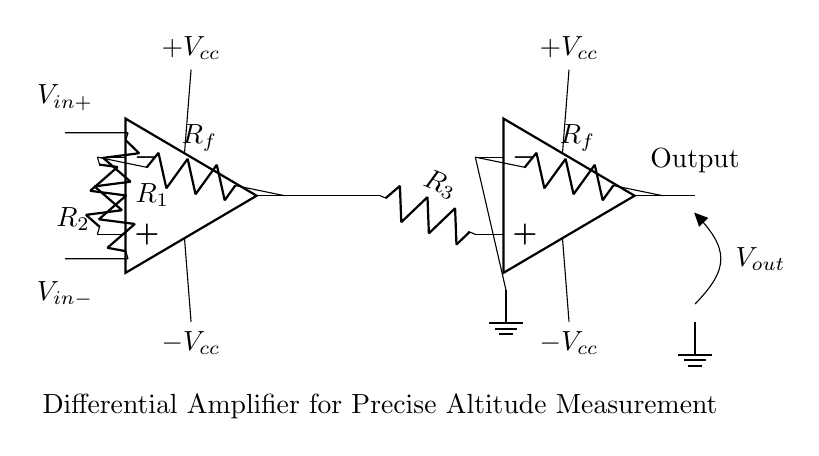What are the two main inputs to the circuit? The main inputs to this differential amplifier circuit are labeled as V_in+ and V_in-. These are the two signal inputs that the amplifier will process.
Answer: V_in+ and V_in- What is the function of the feedback resistors in this circuit? The feedback resistors, labeled R_f, regulate the gain of the amplifier by providing feedback from the output to the inverting input, stabilizing the circuit's performance and controlling the amplifier's output voltage based on the input signals.
Answer: Control gain How many operational amplifiers are used in this circuit? Upon examining the circuit, there are two operational amplifiers present, denoted as opamp1 and opamp2. Each serves a distinct stage in the amplification process.
Answer: Two What is the output voltage of the circuit labeled as? The output voltage from this differential amplifier is labeled as V_out, which represents the amplified difference between the input signals after processing through the circuit.
Answer: V_out What is the purpose of resistor R_3 in the circuit? Resistor R_3 connects the output of the first operational amplifier (opamp1) to the non-inverting input of the second operational amplifier (opamp2), allowing the first stage's output signal to be passed as an input to the second stage, thereby contributing to the overall amplification process.
Answer: Coupling What does the circuit primarily measure? The circuit is designed for precise altitude measurement, indicating that it is utilized to accurately capture and amplify signals related to changes in altitude for aerospace applications.
Answer: Altitude measurement What type of amplifier is represented in this circuit? This circuit is specifically a differential amplifier, as it processes two input signals to produce an output that is proportional to the difference between them. This feature is essential for canceling out common-mode noise and enhancing measurement accuracy in altitude sensing.
Answer: Differential amplifier 